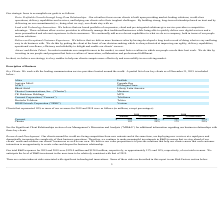From Csg Systems International's financial document, What are the customers that represent 10% or more of the company's revenue in 2019? The document shows two values: Comcast and Charter. From the document: "Comcast Corporation (“Comcast”) Telefónica Charter 195 20% 179 20%..." Also, can you calculate: What is the total revenue earned from Comcast in 2018 and 2019? Based on the calculation: $(229 + 221) , the result is 450 (in millions). This is based on the information: "Comcast $ 229 23% $ 221 25% Comcast $ 229 23% $ 221 25%..." The key data points involved are: 221, 229. Also, can you calculate: What is the average revenue earned by Comcast between 2018 and 2019? To answer this question, I need to perform calculations using the financial data. The calculation is: $(229 + 221)/2 , which equals 225 (in millions). This is based on the information: "Comcast $ 229 23% $ 221 25% Comcast $ 229 23% $ 221 25%..." The key data points involved are: 221, 229. Also, What is the company's R&D expenses in 2018? According to the financial document, $128.0 million. The relevant text states: "Our total R&D expenses for 2019 and 2018 were $128.0 million and $124.0 million, respectively, or approximately 13% and 14%, respectively, of our total revenues...." Also, Who does the company work with? Leading communication service providers located around the world. The document states: "iption of Business Key Clients . We work with the leading communication service providers located around the world. A partial list of our key clients ..." Also, How many companies individually account for 10% or more of the revenue of the company in 2019?  Counting the relevant items in the document: Comcast, Charter, I find 2 instances. The key data points involved are: Charter, Comcast. 